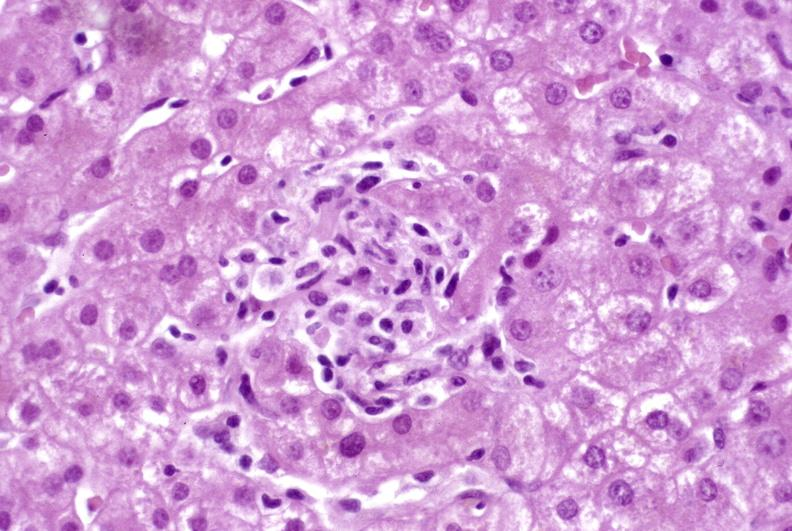what does this image show?
Answer the question using a single word or phrase. Granulomas 